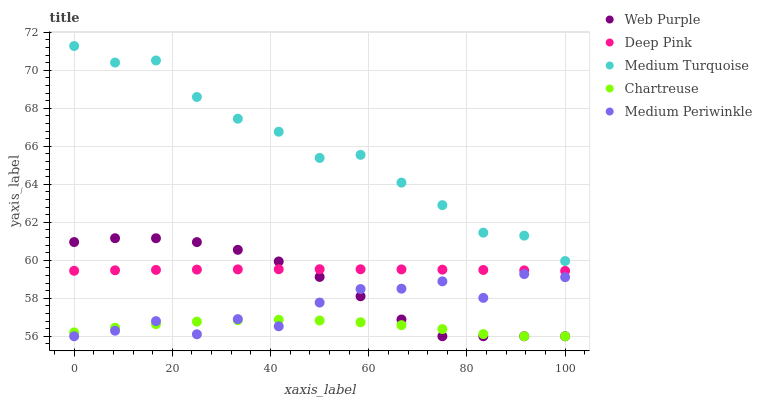Does Chartreuse have the minimum area under the curve?
Answer yes or no. Yes. Does Medium Turquoise have the maximum area under the curve?
Answer yes or no. Yes. Does Deep Pink have the minimum area under the curve?
Answer yes or no. No. Does Deep Pink have the maximum area under the curve?
Answer yes or no. No. Is Deep Pink the smoothest?
Answer yes or no. Yes. Is Medium Periwinkle the roughest?
Answer yes or no. Yes. Is Medium Periwinkle the smoothest?
Answer yes or no. No. Is Deep Pink the roughest?
Answer yes or no. No. Does Web Purple have the lowest value?
Answer yes or no. Yes. Does Deep Pink have the lowest value?
Answer yes or no. No. Does Medium Turquoise have the highest value?
Answer yes or no. Yes. Does Deep Pink have the highest value?
Answer yes or no. No. Is Medium Periwinkle less than Medium Turquoise?
Answer yes or no. Yes. Is Medium Turquoise greater than Chartreuse?
Answer yes or no. Yes. Does Chartreuse intersect Medium Periwinkle?
Answer yes or no. Yes. Is Chartreuse less than Medium Periwinkle?
Answer yes or no. No. Is Chartreuse greater than Medium Periwinkle?
Answer yes or no. No. Does Medium Periwinkle intersect Medium Turquoise?
Answer yes or no. No. 